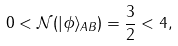Convert formula to latex. <formula><loc_0><loc_0><loc_500><loc_500>0 < \mathcal { N } ( | \phi \rangle _ { A B } ) = \frac { 3 } { 2 } < 4 ,</formula> 